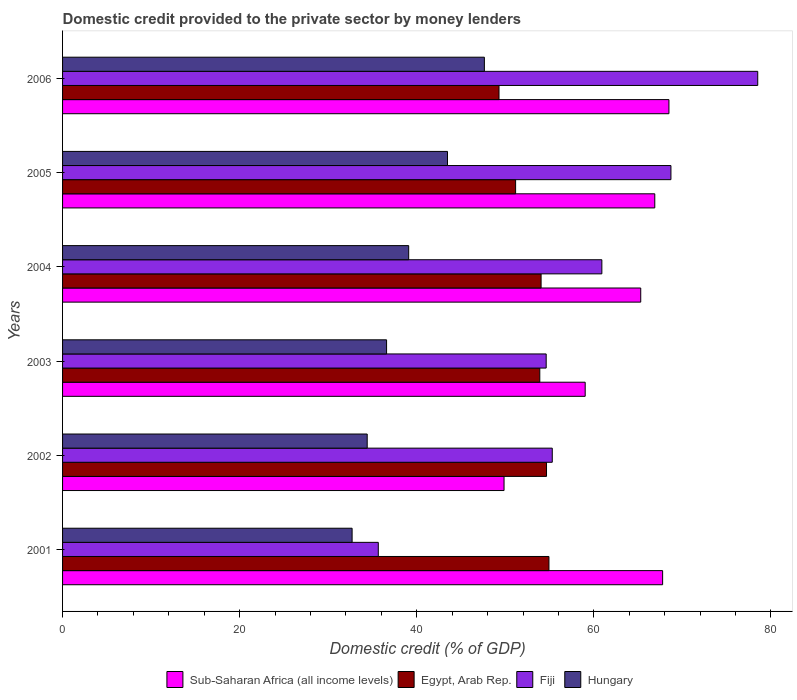How many different coloured bars are there?
Your answer should be compact. 4. How many groups of bars are there?
Make the answer very short. 6. Are the number of bars on each tick of the Y-axis equal?
Offer a very short reply. Yes. How many bars are there on the 2nd tick from the bottom?
Your answer should be very brief. 4. What is the label of the 3rd group of bars from the top?
Keep it short and to the point. 2004. What is the domestic credit provided to the private sector by money lenders in Egypt, Arab Rep. in 2003?
Keep it short and to the point. 53.9. Across all years, what is the maximum domestic credit provided to the private sector by money lenders in Egypt, Arab Rep.?
Provide a short and direct response. 54.93. Across all years, what is the minimum domestic credit provided to the private sector by money lenders in Fiji?
Your answer should be compact. 35.66. In which year was the domestic credit provided to the private sector by money lenders in Fiji maximum?
Provide a short and direct response. 2006. In which year was the domestic credit provided to the private sector by money lenders in Sub-Saharan Africa (all income levels) minimum?
Your answer should be compact. 2002. What is the total domestic credit provided to the private sector by money lenders in Sub-Saharan Africa (all income levels) in the graph?
Keep it short and to the point. 377.31. What is the difference between the domestic credit provided to the private sector by money lenders in Hungary in 2003 and that in 2004?
Provide a short and direct response. -2.5. What is the difference between the domestic credit provided to the private sector by money lenders in Fiji in 2003 and the domestic credit provided to the private sector by money lenders in Hungary in 2002?
Provide a succinct answer. 20.21. What is the average domestic credit provided to the private sector by money lenders in Fiji per year?
Your answer should be very brief. 58.95. In the year 2001, what is the difference between the domestic credit provided to the private sector by money lenders in Egypt, Arab Rep. and domestic credit provided to the private sector by money lenders in Fiji?
Your answer should be very brief. 19.27. What is the ratio of the domestic credit provided to the private sector by money lenders in Fiji in 2002 to that in 2005?
Your answer should be very brief. 0.8. What is the difference between the highest and the second highest domestic credit provided to the private sector by money lenders in Sub-Saharan Africa (all income levels)?
Provide a succinct answer. 0.71. What is the difference between the highest and the lowest domestic credit provided to the private sector by money lenders in Sub-Saharan Africa (all income levels)?
Your answer should be compact. 18.62. In how many years, is the domestic credit provided to the private sector by money lenders in Egypt, Arab Rep. greater than the average domestic credit provided to the private sector by money lenders in Egypt, Arab Rep. taken over all years?
Offer a very short reply. 4. What does the 2nd bar from the top in 2002 represents?
Your answer should be very brief. Fiji. What does the 2nd bar from the bottom in 2005 represents?
Keep it short and to the point. Egypt, Arab Rep. Is it the case that in every year, the sum of the domestic credit provided to the private sector by money lenders in Fiji and domestic credit provided to the private sector by money lenders in Sub-Saharan Africa (all income levels) is greater than the domestic credit provided to the private sector by money lenders in Egypt, Arab Rep.?
Provide a succinct answer. Yes. How many bars are there?
Give a very brief answer. 24. Are all the bars in the graph horizontal?
Your answer should be compact. Yes. Does the graph contain any zero values?
Your answer should be very brief. No. Does the graph contain grids?
Your answer should be very brief. No. Where does the legend appear in the graph?
Keep it short and to the point. Bottom center. How many legend labels are there?
Offer a terse response. 4. How are the legend labels stacked?
Make the answer very short. Horizontal. What is the title of the graph?
Provide a short and direct response. Domestic credit provided to the private sector by money lenders. Does "Faeroe Islands" appear as one of the legend labels in the graph?
Offer a terse response. No. What is the label or title of the X-axis?
Your answer should be compact. Domestic credit (% of GDP). What is the Domestic credit (% of GDP) of Sub-Saharan Africa (all income levels) in 2001?
Your answer should be very brief. 67.77. What is the Domestic credit (% of GDP) in Egypt, Arab Rep. in 2001?
Your answer should be very brief. 54.93. What is the Domestic credit (% of GDP) of Fiji in 2001?
Provide a short and direct response. 35.66. What is the Domestic credit (% of GDP) of Hungary in 2001?
Provide a short and direct response. 32.7. What is the Domestic credit (% of GDP) in Sub-Saharan Africa (all income levels) in 2002?
Your answer should be very brief. 49.86. What is the Domestic credit (% of GDP) of Egypt, Arab Rep. in 2002?
Ensure brevity in your answer.  54.66. What is the Domestic credit (% of GDP) in Fiji in 2002?
Your response must be concise. 55.31. What is the Domestic credit (% of GDP) of Hungary in 2002?
Keep it short and to the point. 34.41. What is the Domestic credit (% of GDP) of Sub-Saharan Africa (all income levels) in 2003?
Provide a short and direct response. 59.02. What is the Domestic credit (% of GDP) in Egypt, Arab Rep. in 2003?
Your response must be concise. 53.9. What is the Domestic credit (% of GDP) of Fiji in 2003?
Your answer should be very brief. 54.62. What is the Domestic credit (% of GDP) of Hungary in 2003?
Provide a succinct answer. 36.59. What is the Domestic credit (% of GDP) in Sub-Saharan Africa (all income levels) in 2004?
Offer a very short reply. 65.3. What is the Domestic credit (% of GDP) of Egypt, Arab Rep. in 2004?
Your response must be concise. 54.04. What is the Domestic credit (% of GDP) in Fiji in 2004?
Provide a short and direct response. 60.91. What is the Domestic credit (% of GDP) of Hungary in 2004?
Your answer should be compact. 39.09. What is the Domestic credit (% of GDP) of Sub-Saharan Africa (all income levels) in 2005?
Your response must be concise. 66.88. What is the Domestic credit (% of GDP) of Egypt, Arab Rep. in 2005?
Your answer should be compact. 51.17. What is the Domestic credit (% of GDP) of Fiji in 2005?
Provide a short and direct response. 68.71. What is the Domestic credit (% of GDP) of Hungary in 2005?
Your response must be concise. 43.47. What is the Domestic credit (% of GDP) in Sub-Saharan Africa (all income levels) in 2006?
Provide a succinct answer. 68.48. What is the Domestic credit (% of GDP) in Egypt, Arab Rep. in 2006?
Offer a terse response. 49.29. What is the Domestic credit (% of GDP) in Fiji in 2006?
Your answer should be very brief. 78.51. What is the Domestic credit (% of GDP) in Hungary in 2006?
Keep it short and to the point. 47.64. Across all years, what is the maximum Domestic credit (% of GDP) in Sub-Saharan Africa (all income levels)?
Keep it short and to the point. 68.48. Across all years, what is the maximum Domestic credit (% of GDP) in Egypt, Arab Rep.?
Ensure brevity in your answer.  54.93. Across all years, what is the maximum Domestic credit (% of GDP) of Fiji?
Provide a succinct answer. 78.51. Across all years, what is the maximum Domestic credit (% of GDP) in Hungary?
Give a very brief answer. 47.64. Across all years, what is the minimum Domestic credit (% of GDP) in Sub-Saharan Africa (all income levels)?
Offer a very short reply. 49.86. Across all years, what is the minimum Domestic credit (% of GDP) in Egypt, Arab Rep.?
Provide a succinct answer. 49.29. Across all years, what is the minimum Domestic credit (% of GDP) in Fiji?
Ensure brevity in your answer.  35.66. Across all years, what is the minimum Domestic credit (% of GDP) of Hungary?
Offer a very short reply. 32.7. What is the total Domestic credit (% of GDP) of Sub-Saharan Africa (all income levels) in the graph?
Make the answer very short. 377.31. What is the total Domestic credit (% of GDP) of Egypt, Arab Rep. in the graph?
Keep it short and to the point. 317.98. What is the total Domestic credit (% of GDP) in Fiji in the graph?
Your response must be concise. 353.7. What is the total Domestic credit (% of GDP) in Hungary in the graph?
Ensure brevity in your answer.  233.9. What is the difference between the Domestic credit (% of GDP) in Sub-Saharan Africa (all income levels) in 2001 and that in 2002?
Offer a terse response. 17.91. What is the difference between the Domestic credit (% of GDP) in Egypt, Arab Rep. in 2001 and that in 2002?
Your answer should be very brief. 0.28. What is the difference between the Domestic credit (% of GDP) of Fiji in 2001 and that in 2002?
Your answer should be compact. -19.65. What is the difference between the Domestic credit (% of GDP) in Hungary in 2001 and that in 2002?
Your response must be concise. -1.71. What is the difference between the Domestic credit (% of GDP) of Sub-Saharan Africa (all income levels) in 2001 and that in 2003?
Offer a terse response. 8.75. What is the difference between the Domestic credit (% of GDP) in Egypt, Arab Rep. in 2001 and that in 2003?
Your response must be concise. 1.03. What is the difference between the Domestic credit (% of GDP) of Fiji in 2001 and that in 2003?
Give a very brief answer. -18.96. What is the difference between the Domestic credit (% of GDP) in Hungary in 2001 and that in 2003?
Provide a succinct answer. -3.89. What is the difference between the Domestic credit (% of GDP) in Sub-Saharan Africa (all income levels) in 2001 and that in 2004?
Provide a succinct answer. 2.47. What is the difference between the Domestic credit (% of GDP) in Egypt, Arab Rep. in 2001 and that in 2004?
Keep it short and to the point. 0.89. What is the difference between the Domestic credit (% of GDP) of Fiji in 2001 and that in 2004?
Your answer should be very brief. -25.25. What is the difference between the Domestic credit (% of GDP) of Hungary in 2001 and that in 2004?
Your response must be concise. -6.39. What is the difference between the Domestic credit (% of GDP) in Sub-Saharan Africa (all income levels) in 2001 and that in 2005?
Ensure brevity in your answer.  0.89. What is the difference between the Domestic credit (% of GDP) of Egypt, Arab Rep. in 2001 and that in 2005?
Your answer should be very brief. 3.77. What is the difference between the Domestic credit (% of GDP) of Fiji in 2001 and that in 2005?
Provide a short and direct response. -33.05. What is the difference between the Domestic credit (% of GDP) of Hungary in 2001 and that in 2005?
Offer a terse response. -10.77. What is the difference between the Domestic credit (% of GDP) in Sub-Saharan Africa (all income levels) in 2001 and that in 2006?
Your response must be concise. -0.71. What is the difference between the Domestic credit (% of GDP) of Egypt, Arab Rep. in 2001 and that in 2006?
Offer a terse response. 5.64. What is the difference between the Domestic credit (% of GDP) of Fiji in 2001 and that in 2006?
Your answer should be compact. -42.85. What is the difference between the Domestic credit (% of GDP) in Hungary in 2001 and that in 2006?
Make the answer very short. -14.94. What is the difference between the Domestic credit (% of GDP) in Sub-Saharan Africa (all income levels) in 2002 and that in 2003?
Your response must be concise. -9.16. What is the difference between the Domestic credit (% of GDP) in Egypt, Arab Rep. in 2002 and that in 2003?
Offer a terse response. 0.76. What is the difference between the Domestic credit (% of GDP) in Fiji in 2002 and that in 2003?
Provide a succinct answer. 0.69. What is the difference between the Domestic credit (% of GDP) of Hungary in 2002 and that in 2003?
Give a very brief answer. -2.19. What is the difference between the Domestic credit (% of GDP) of Sub-Saharan Africa (all income levels) in 2002 and that in 2004?
Offer a terse response. -15.44. What is the difference between the Domestic credit (% of GDP) in Egypt, Arab Rep. in 2002 and that in 2004?
Offer a terse response. 0.61. What is the difference between the Domestic credit (% of GDP) of Fiji in 2002 and that in 2004?
Provide a short and direct response. -5.6. What is the difference between the Domestic credit (% of GDP) of Hungary in 2002 and that in 2004?
Keep it short and to the point. -4.68. What is the difference between the Domestic credit (% of GDP) in Sub-Saharan Africa (all income levels) in 2002 and that in 2005?
Your answer should be compact. -17.02. What is the difference between the Domestic credit (% of GDP) of Egypt, Arab Rep. in 2002 and that in 2005?
Offer a very short reply. 3.49. What is the difference between the Domestic credit (% of GDP) of Fiji in 2002 and that in 2005?
Make the answer very short. -13.4. What is the difference between the Domestic credit (% of GDP) of Hungary in 2002 and that in 2005?
Give a very brief answer. -9.07. What is the difference between the Domestic credit (% of GDP) of Sub-Saharan Africa (all income levels) in 2002 and that in 2006?
Your answer should be compact. -18.62. What is the difference between the Domestic credit (% of GDP) in Egypt, Arab Rep. in 2002 and that in 2006?
Make the answer very short. 5.36. What is the difference between the Domestic credit (% of GDP) in Fiji in 2002 and that in 2006?
Give a very brief answer. -23.2. What is the difference between the Domestic credit (% of GDP) in Hungary in 2002 and that in 2006?
Provide a short and direct response. -13.23. What is the difference between the Domestic credit (% of GDP) in Sub-Saharan Africa (all income levels) in 2003 and that in 2004?
Offer a very short reply. -6.27. What is the difference between the Domestic credit (% of GDP) of Egypt, Arab Rep. in 2003 and that in 2004?
Make the answer very short. -0.15. What is the difference between the Domestic credit (% of GDP) in Fiji in 2003 and that in 2004?
Keep it short and to the point. -6.29. What is the difference between the Domestic credit (% of GDP) of Hungary in 2003 and that in 2004?
Give a very brief answer. -2.5. What is the difference between the Domestic credit (% of GDP) in Sub-Saharan Africa (all income levels) in 2003 and that in 2005?
Your response must be concise. -7.86. What is the difference between the Domestic credit (% of GDP) of Egypt, Arab Rep. in 2003 and that in 2005?
Make the answer very short. 2.73. What is the difference between the Domestic credit (% of GDP) of Fiji in 2003 and that in 2005?
Offer a very short reply. -14.09. What is the difference between the Domestic credit (% of GDP) in Hungary in 2003 and that in 2005?
Your answer should be very brief. -6.88. What is the difference between the Domestic credit (% of GDP) in Sub-Saharan Africa (all income levels) in 2003 and that in 2006?
Keep it short and to the point. -9.46. What is the difference between the Domestic credit (% of GDP) in Egypt, Arab Rep. in 2003 and that in 2006?
Make the answer very short. 4.61. What is the difference between the Domestic credit (% of GDP) of Fiji in 2003 and that in 2006?
Provide a succinct answer. -23.89. What is the difference between the Domestic credit (% of GDP) in Hungary in 2003 and that in 2006?
Your answer should be compact. -11.05. What is the difference between the Domestic credit (% of GDP) of Sub-Saharan Africa (all income levels) in 2004 and that in 2005?
Your answer should be very brief. -1.59. What is the difference between the Domestic credit (% of GDP) of Egypt, Arab Rep. in 2004 and that in 2005?
Give a very brief answer. 2.88. What is the difference between the Domestic credit (% of GDP) in Fiji in 2004 and that in 2005?
Keep it short and to the point. -7.8. What is the difference between the Domestic credit (% of GDP) of Hungary in 2004 and that in 2005?
Ensure brevity in your answer.  -4.38. What is the difference between the Domestic credit (% of GDP) in Sub-Saharan Africa (all income levels) in 2004 and that in 2006?
Your answer should be very brief. -3.19. What is the difference between the Domestic credit (% of GDP) of Egypt, Arab Rep. in 2004 and that in 2006?
Provide a succinct answer. 4.75. What is the difference between the Domestic credit (% of GDP) in Fiji in 2004 and that in 2006?
Provide a succinct answer. -17.6. What is the difference between the Domestic credit (% of GDP) in Hungary in 2004 and that in 2006?
Offer a terse response. -8.55. What is the difference between the Domestic credit (% of GDP) in Sub-Saharan Africa (all income levels) in 2005 and that in 2006?
Make the answer very short. -1.6. What is the difference between the Domestic credit (% of GDP) in Egypt, Arab Rep. in 2005 and that in 2006?
Ensure brevity in your answer.  1.87. What is the difference between the Domestic credit (% of GDP) of Fiji in 2005 and that in 2006?
Your answer should be compact. -9.8. What is the difference between the Domestic credit (% of GDP) of Hungary in 2005 and that in 2006?
Make the answer very short. -4.17. What is the difference between the Domestic credit (% of GDP) in Sub-Saharan Africa (all income levels) in 2001 and the Domestic credit (% of GDP) in Egypt, Arab Rep. in 2002?
Your response must be concise. 13.11. What is the difference between the Domestic credit (% of GDP) of Sub-Saharan Africa (all income levels) in 2001 and the Domestic credit (% of GDP) of Fiji in 2002?
Your answer should be compact. 12.46. What is the difference between the Domestic credit (% of GDP) of Sub-Saharan Africa (all income levels) in 2001 and the Domestic credit (% of GDP) of Hungary in 2002?
Provide a succinct answer. 33.36. What is the difference between the Domestic credit (% of GDP) of Egypt, Arab Rep. in 2001 and the Domestic credit (% of GDP) of Fiji in 2002?
Your answer should be compact. -0.37. What is the difference between the Domestic credit (% of GDP) in Egypt, Arab Rep. in 2001 and the Domestic credit (% of GDP) in Hungary in 2002?
Your response must be concise. 20.53. What is the difference between the Domestic credit (% of GDP) of Fiji in 2001 and the Domestic credit (% of GDP) of Hungary in 2002?
Offer a terse response. 1.25. What is the difference between the Domestic credit (% of GDP) in Sub-Saharan Africa (all income levels) in 2001 and the Domestic credit (% of GDP) in Egypt, Arab Rep. in 2003?
Make the answer very short. 13.87. What is the difference between the Domestic credit (% of GDP) of Sub-Saharan Africa (all income levels) in 2001 and the Domestic credit (% of GDP) of Fiji in 2003?
Provide a short and direct response. 13.15. What is the difference between the Domestic credit (% of GDP) in Sub-Saharan Africa (all income levels) in 2001 and the Domestic credit (% of GDP) in Hungary in 2003?
Give a very brief answer. 31.18. What is the difference between the Domestic credit (% of GDP) of Egypt, Arab Rep. in 2001 and the Domestic credit (% of GDP) of Fiji in 2003?
Give a very brief answer. 0.31. What is the difference between the Domestic credit (% of GDP) in Egypt, Arab Rep. in 2001 and the Domestic credit (% of GDP) in Hungary in 2003?
Make the answer very short. 18.34. What is the difference between the Domestic credit (% of GDP) of Fiji in 2001 and the Domestic credit (% of GDP) of Hungary in 2003?
Your response must be concise. -0.94. What is the difference between the Domestic credit (% of GDP) in Sub-Saharan Africa (all income levels) in 2001 and the Domestic credit (% of GDP) in Egypt, Arab Rep. in 2004?
Your response must be concise. 13.72. What is the difference between the Domestic credit (% of GDP) of Sub-Saharan Africa (all income levels) in 2001 and the Domestic credit (% of GDP) of Fiji in 2004?
Keep it short and to the point. 6.86. What is the difference between the Domestic credit (% of GDP) in Sub-Saharan Africa (all income levels) in 2001 and the Domestic credit (% of GDP) in Hungary in 2004?
Give a very brief answer. 28.68. What is the difference between the Domestic credit (% of GDP) of Egypt, Arab Rep. in 2001 and the Domestic credit (% of GDP) of Fiji in 2004?
Make the answer very short. -5.97. What is the difference between the Domestic credit (% of GDP) in Egypt, Arab Rep. in 2001 and the Domestic credit (% of GDP) in Hungary in 2004?
Your response must be concise. 15.84. What is the difference between the Domestic credit (% of GDP) in Fiji in 2001 and the Domestic credit (% of GDP) in Hungary in 2004?
Your answer should be compact. -3.43. What is the difference between the Domestic credit (% of GDP) in Sub-Saharan Africa (all income levels) in 2001 and the Domestic credit (% of GDP) in Egypt, Arab Rep. in 2005?
Provide a short and direct response. 16.6. What is the difference between the Domestic credit (% of GDP) in Sub-Saharan Africa (all income levels) in 2001 and the Domestic credit (% of GDP) in Fiji in 2005?
Give a very brief answer. -0.94. What is the difference between the Domestic credit (% of GDP) of Sub-Saharan Africa (all income levels) in 2001 and the Domestic credit (% of GDP) of Hungary in 2005?
Provide a succinct answer. 24.3. What is the difference between the Domestic credit (% of GDP) in Egypt, Arab Rep. in 2001 and the Domestic credit (% of GDP) in Fiji in 2005?
Keep it short and to the point. -13.78. What is the difference between the Domestic credit (% of GDP) in Egypt, Arab Rep. in 2001 and the Domestic credit (% of GDP) in Hungary in 2005?
Provide a succinct answer. 11.46. What is the difference between the Domestic credit (% of GDP) of Fiji in 2001 and the Domestic credit (% of GDP) of Hungary in 2005?
Provide a succinct answer. -7.82. What is the difference between the Domestic credit (% of GDP) in Sub-Saharan Africa (all income levels) in 2001 and the Domestic credit (% of GDP) in Egypt, Arab Rep. in 2006?
Your response must be concise. 18.48. What is the difference between the Domestic credit (% of GDP) in Sub-Saharan Africa (all income levels) in 2001 and the Domestic credit (% of GDP) in Fiji in 2006?
Give a very brief answer. -10.74. What is the difference between the Domestic credit (% of GDP) in Sub-Saharan Africa (all income levels) in 2001 and the Domestic credit (% of GDP) in Hungary in 2006?
Offer a terse response. 20.13. What is the difference between the Domestic credit (% of GDP) in Egypt, Arab Rep. in 2001 and the Domestic credit (% of GDP) in Fiji in 2006?
Your answer should be compact. -23.58. What is the difference between the Domestic credit (% of GDP) of Egypt, Arab Rep. in 2001 and the Domestic credit (% of GDP) of Hungary in 2006?
Provide a short and direct response. 7.29. What is the difference between the Domestic credit (% of GDP) of Fiji in 2001 and the Domestic credit (% of GDP) of Hungary in 2006?
Keep it short and to the point. -11.98. What is the difference between the Domestic credit (% of GDP) of Sub-Saharan Africa (all income levels) in 2002 and the Domestic credit (% of GDP) of Egypt, Arab Rep. in 2003?
Provide a succinct answer. -4.04. What is the difference between the Domestic credit (% of GDP) in Sub-Saharan Africa (all income levels) in 2002 and the Domestic credit (% of GDP) in Fiji in 2003?
Your answer should be very brief. -4.76. What is the difference between the Domestic credit (% of GDP) in Sub-Saharan Africa (all income levels) in 2002 and the Domestic credit (% of GDP) in Hungary in 2003?
Ensure brevity in your answer.  13.27. What is the difference between the Domestic credit (% of GDP) in Egypt, Arab Rep. in 2002 and the Domestic credit (% of GDP) in Fiji in 2003?
Provide a short and direct response. 0.04. What is the difference between the Domestic credit (% of GDP) in Egypt, Arab Rep. in 2002 and the Domestic credit (% of GDP) in Hungary in 2003?
Give a very brief answer. 18.06. What is the difference between the Domestic credit (% of GDP) of Fiji in 2002 and the Domestic credit (% of GDP) of Hungary in 2003?
Your answer should be very brief. 18.71. What is the difference between the Domestic credit (% of GDP) of Sub-Saharan Africa (all income levels) in 2002 and the Domestic credit (% of GDP) of Egypt, Arab Rep. in 2004?
Keep it short and to the point. -4.18. What is the difference between the Domestic credit (% of GDP) in Sub-Saharan Africa (all income levels) in 2002 and the Domestic credit (% of GDP) in Fiji in 2004?
Ensure brevity in your answer.  -11.05. What is the difference between the Domestic credit (% of GDP) of Sub-Saharan Africa (all income levels) in 2002 and the Domestic credit (% of GDP) of Hungary in 2004?
Your answer should be very brief. 10.77. What is the difference between the Domestic credit (% of GDP) of Egypt, Arab Rep. in 2002 and the Domestic credit (% of GDP) of Fiji in 2004?
Keep it short and to the point. -6.25. What is the difference between the Domestic credit (% of GDP) of Egypt, Arab Rep. in 2002 and the Domestic credit (% of GDP) of Hungary in 2004?
Keep it short and to the point. 15.57. What is the difference between the Domestic credit (% of GDP) of Fiji in 2002 and the Domestic credit (% of GDP) of Hungary in 2004?
Your answer should be very brief. 16.22. What is the difference between the Domestic credit (% of GDP) of Sub-Saharan Africa (all income levels) in 2002 and the Domestic credit (% of GDP) of Egypt, Arab Rep. in 2005?
Your response must be concise. -1.31. What is the difference between the Domestic credit (% of GDP) of Sub-Saharan Africa (all income levels) in 2002 and the Domestic credit (% of GDP) of Fiji in 2005?
Offer a terse response. -18.85. What is the difference between the Domestic credit (% of GDP) of Sub-Saharan Africa (all income levels) in 2002 and the Domestic credit (% of GDP) of Hungary in 2005?
Your answer should be compact. 6.39. What is the difference between the Domestic credit (% of GDP) of Egypt, Arab Rep. in 2002 and the Domestic credit (% of GDP) of Fiji in 2005?
Ensure brevity in your answer.  -14.05. What is the difference between the Domestic credit (% of GDP) in Egypt, Arab Rep. in 2002 and the Domestic credit (% of GDP) in Hungary in 2005?
Make the answer very short. 11.18. What is the difference between the Domestic credit (% of GDP) of Fiji in 2002 and the Domestic credit (% of GDP) of Hungary in 2005?
Your answer should be very brief. 11.83. What is the difference between the Domestic credit (% of GDP) of Sub-Saharan Africa (all income levels) in 2002 and the Domestic credit (% of GDP) of Egypt, Arab Rep. in 2006?
Offer a terse response. 0.57. What is the difference between the Domestic credit (% of GDP) in Sub-Saharan Africa (all income levels) in 2002 and the Domestic credit (% of GDP) in Fiji in 2006?
Ensure brevity in your answer.  -28.65. What is the difference between the Domestic credit (% of GDP) in Sub-Saharan Africa (all income levels) in 2002 and the Domestic credit (% of GDP) in Hungary in 2006?
Keep it short and to the point. 2.22. What is the difference between the Domestic credit (% of GDP) in Egypt, Arab Rep. in 2002 and the Domestic credit (% of GDP) in Fiji in 2006?
Ensure brevity in your answer.  -23.85. What is the difference between the Domestic credit (% of GDP) in Egypt, Arab Rep. in 2002 and the Domestic credit (% of GDP) in Hungary in 2006?
Make the answer very short. 7.02. What is the difference between the Domestic credit (% of GDP) of Fiji in 2002 and the Domestic credit (% of GDP) of Hungary in 2006?
Provide a succinct answer. 7.67. What is the difference between the Domestic credit (% of GDP) in Sub-Saharan Africa (all income levels) in 2003 and the Domestic credit (% of GDP) in Egypt, Arab Rep. in 2004?
Provide a succinct answer. 4.98. What is the difference between the Domestic credit (% of GDP) in Sub-Saharan Africa (all income levels) in 2003 and the Domestic credit (% of GDP) in Fiji in 2004?
Provide a short and direct response. -1.88. What is the difference between the Domestic credit (% of GDP) of Sub-Saharan Africa (all income levels) in 2003 and the Domestic credit (% of GDP) of Hungary in 2004?
Provide a succinct answer. 19.93. What is the difference between the Domestic credit (% of GDP) in Egypt, Arab Rep. in 2003 and the Domestic credit (% of GDP) in Fiji in 2004?
Your answer should be very brief. -7.01. What is the difference between the Domestic credit (% of GDP) in Egypt, Arab Rep. in 2003 and the Domestic credit (% of GDP) in Hungary in 2004?
Offer a terse response. 14.81. What is the difference between the Domestic credit (% of GDP) in Fiji in 2003 and the Domestic credit (% of GDP) in Hungary in 2004?
Give a very brief answer. 15.53. What is the difference between the Domestic credit (% of GDP) in Sub-Saharan Africa (all income levels) in 2003 and the Domestic credit (% of GDP) in Egypt, Arab Rep. in 2005?
Offer a very short reply. 7.86. What is the difference between the Domestic credit (% of GDP) of Sub-Saharan Africa (all income levels) in 2003 and the Domestic credit (% of GDP) of Fiji in 2005?
Provide a short and direct response. -9.68. What is the difference between the Domestic credit (% of GDP) of Sub-Saharan Africa (all income levels) in 2003 and the Domestic credit (% of GDP) of Hungary in 2005?
Your answer should be compact. 15.55. What is the difference between the Domestic credit (% of GDP) in Egypt, Arab Rep. in 2003 and the Domestic credit (% of GDP) in Fiji in 2005?
Make the answer very short. -14.81. What is the difference between the Domestic credit (% of GDP) of Egypt, Arab Rep. in 2003 and the Domestic credit (% of GDP) of Hungary in 2005?
Ensure brevity in your answer.  10.43. What is the difference between the Domestic credit (% of GDP) of Fiji in 2003 and the Domestic credit (% of GDP) of Hungary in 2005?
Give a very brief answer. 11.15. What is the difference between the Domestic credit (% of GDP) of Sub-Saharan Africa (all income levels) in 2003 and the Domestic credit (% of GDP) of Egypt, Arab Rep. in 2006?
Your answer should be compact. 9.73. What is the difference between the Domestic credit (% of GDP) of Sub-Saharan Africa (all income levels) in 2003 and the Domestic credit (% of GDP) of Fiji in 2006?
Your answer should be very brief. -19.49. What is the difference between the Domestic credit (% of GDP) in Sub-Saharan Africa (all income levels) in 2003 and the Domestic credit (% of GDP) in Hungary in 2006?
Your answer should be very brief. 11.38. What is the difference between the Domestic credit (% of GDP) in Egypt, Arab Rep. in 2003 and the Domestic credit (% of GDP) in Fiji in 2006?
Give a very brief answer. -24.61. What is the difference between the Domestic credit (% of GDP) of Egypt, Arab Rep. in 2003 and the Domestic credit (% of GDP) of Hungary in 2006?
Offer a very short reply. 6.26. What is the difference between the Domestic credit (% of GDP) in Fiji in 2003 and the Domestic credit (% of GDP) in Hungary in 2006?
Make the answer very short. 6.98. What is the difference between the Domestic credit (% of GDP) of Sub-Saharan Africa (all income levels) in 2004 and the Domestic credit (% of GDP) of Egypt, Arab Rep. in 2005?
Offer a terse response. 14.13. What is the difference between the Domestic credit (% of GDP) in Sub-Saharan Africa (all income levels) in 2004 and the Domestic credit (% of GDP) in Fiji in 2005?
Offer a very short reply. -3.41. What is the difference between the Domestic credit (% of GDP) of Sub-Saharan Africa (all income levels) in 2004 and the Domestic credit (% of GDP) of Hungary in 2005?
Provide a succinct answer. 21.82. What is the difference between the Domestic credit (% of GDP) in Egypt, Arab Rep. in 2004 and the Domestic credit (% of GDP) in Fiji in 2005?
Make the answer very short. -14.66. What is the difference between the Domestic credit (% of GDP) in Egypt, Arab Rep. in 2004 and the Domestic credit (% of GDP) in Hungary in 2005?
Your answer should be very brief. 10.57. What is the difference between the Domestic credit (% of GDP) of Fiji in 2004 and the Domestic credit (% of GDP) of Hungary in 2005?
Give a very brief answer. 17.43. What is the difference between the Domestic credit (% of GDP) in Sub-Saharan Africa (all income levels) in 2004 and the Domestic credit (% of GDP) in Egypt, Arab Rep. in 2006?
Ensure brevity in your answer.  16. What is the difference between the Domestic credit (% of GDP) of Sub-Saharan Africa (all income levels) in 2004 and the Domestic credit (% of GDP) of Fiji in 2006?
Your answer should be very brief. -13.21. What is the difference between the Domestic credit (% of GDP) of Sub-Saharan Africa (all income levels) in 2004 and the Domestic credit (% of GDP) of Hungary in 2006?
Ensure brevity in your answer.  17.66. What is the difference between the Domestic credit (% of GDP) of Egypt, Arab Rep. in 2004 and the Domestic credit (% of GDP) of Fiji in 2006?
Your answer should be compact. -24.47. What is the difference between the Domestic credit (% of GDP) in Egypt, Arab Rep. in 2004 and the Domestic credit (% of GDP) in Hungary in 2006?
Give a very brief answer. 6.41. What is the difference between the Domestic credit (% of GDP) in Fiji in 2004 and the Domestic credit (% of GDP) in Hungary in 2006?
Offer a terse response. 13.27. What is the difference between the Domestic credit (% of GDP) in Sub-Saharan Africa (all income levels) in 2005 and the Domestic credit (% of GDP) in Egypt, Arab Rep. in 2006?
Your answer should be compact. 17.59. What is the difference between the Domestic credit (% of GDP) of Sub-Saharan Africa (all income levels) in 2005 and the Domestic credit (% of GDP) of Fiji in 2006?
Make the answer very short. -11.63. What is the difference between the Domestic credit (% of GDP) in Sub-Saharan Africa (all income levels) in 2005 and the Domestic credit (% of GDP) in Hungary in 2006?
Keep it short and to the point. 19.24. What is the difference between the Domestic credit (% of GDP) in Egypt, Arab Rep. in 2005 and the Domestic credit (% of GDP) in Fiji in 2006?
Give a very brief answer. -27.34. What is the difference between the Domestic credit (% of GDP) of Egypt, Arab Rep. in 2005 and the Domestic credit (% of GDP) of Hungary in 2006?
Offer a terse response. 3.53. What is the difference between the Domestic credit (% of GDP) of Fiji in 2005 and the Domestic credit (% of GDP) of Hungary in 2006?
Give a very brief answer. 21.07. What is the average Domestic credit (% of GDP) of Sub-Saharan Africa (all income levels) per year?
Your answer should be very brief. 62.88. What is the average Domestic credit (% of GDP) of Egypt, Arab Rep. per year?
Your response must be concise. 53. What is the average Domestic credit (% of GDP) of Fiji per year?
Your answer should be very brief. 58.95. What is the average Domestic credit (% of GDP) of Hungary per year?
Offer a terse response. 38.98. In the year 2001, what is the difference between the Domestic credit (% of GDP) of Sub-Saharan Africa (all income levels) and Domestic credit (% of GDP) of Egypt, Arab Rep.?
Offer a terse response. 12.84. In the year 2001, what is the difference between the Domestic credit (% of GDP) of Sub-Saharan Africa (all income levels) and Domestic credit (% of GDP) of Fiji?
Provide a short and direct response. 32.11. In the year 2001, what is the difference between the Domestic credit (% of GDP) in Sub-Saharan Africa (all income levels) and Domestic credit (% of GDP) in Hungary?
Give a very brief answer. 35.07. In the year 2001, what is the difference between the Domestic credit (% of GDP) of Egypt, Arab Rep. and Domestic credit (% of GDP) of Fiji?
Your answer should be very brief. 19.27. In the year 2001, what is the difference between the Domestic credit (% of GDP) of Egypt, Arab Rep. and Domestic credit (% of GDP) of Hungary?
Offer a terse response. 22.23. In the year 2001, what is the difference between the Domestic credit (% of GDP) of Fiji and Domestic credit (% of GDP) of Hungary?
Your response must be concise. 2.96. In the year 2002, what is the difference between the Domestic credit (% of GDP) of Sub-Saharan Africa (all income levels) and Domestic credit (% of GDP) of Egypt, Arab Rep.?
Offer a very short reply. -4.8. In the year 2002, what is the difference between the Domestic credit (% of GDP) in Sub-Saharan Africa (all income levels) and Domestic credit (% of GDP) in Fiji?
Provide a succinct answer. -5.45. In the year 2002, what is the difference between the Domestic credit (% of GDP) in Sub-Saharan Africa (all income levels) and Domestic credit (% of GDP) in Hungary?
Provide a short and direct response. 15.45. In the year 2002, what is the difference between the Domestic credit (% of GDP) of Egypt, Arab Rep. and Domestic credit (% of GDP) of Fiji?
Make the answer very short. -0.65. In the year 2002, what is the difference between the Domestic credit (% of GDP) of Egypt, Arab Rep. and Domestic credit (% of GDP) of Hungary?
Your answer should be compact. 20.25. In the year 2002, what is the difference between the Domestic credit (% of GDP) of Fiji and Domestic credit (% of GDP) of Hungary?
Make the answer very short. 20.9. In the year 2003, what is the difference between the Domestic credit (% of GDP) in Sub-Saharan Africa (all income levels) and Domestic credit (% of GDP) in Egypt, Arab Rep.?
Provide a succinct answer. 5.13. In the year 2003, what is the difference between the Domestic credit (% of GDP) of Sub-Saharan Africa (all income levels) and Domestic credit (% of GDP) of Fiji?
Your answer should be very brief. 4.4. In the year 2003, what is the difference between the Domestic credit (% of GDP) in Sub-Saharan Africa (all income levels) and Domestic credit (% of GDP) in Hungary?
Make the answer very short. 22.43. In the year 2003, what is the difference between the Domestic credit (% of GDP) in Egypt, Arab Rep. and Domestic credit (% of GDP) in Fiji?
Your answer should be compact. -0.72. In the year 2003, what is the difference between the Domestic credit (% of GDP) in Egypt, Arab Rep. and Domestic credit (% of GDP) in Hungary?
Offer a terse response. 17.31. In the year 2003, what is the difference between the Domestic credit (% of GDP) of Fiji and Domestic credit (% of GDP) of Hungary?
Make the answer very short. 18.03. In the year 2004, what is the difference between the Domestic credit (% of GDP) of Sub-Saharan Africa (all income levels) and Domestic credit (% of GDP) of Egypt, Arab Rep.?
Your answer should be very brief. 11.25. In the year 2004, what is the difference between the Domestic credit (% of GDP) of Sub-Saharan Africa (all income levels) and Domestic credit (% of GDP) of Fiji?
Provide a short and direct response. 4.39. In the year 2004, what is the difference between the Domestic credit (% of GDP) of Sub-Saharan Africa (all income levels) and Domestic credit (% of GDP) of Hungary?
Provide a short and direct response. 26.21. In the year 2004, what is the difference between the Domestic credit (% of GDP) in Egypt, Arab Rep. and Domestic credit (% of GDP) in Fiji?
Ensure brevity in your answer.  -6.86. In the year 2004, what is the difference between the Domestic credit (% of GDP) in Egypt, Arab Rep. and Domestic credit (% of GDP) in Hungary?
Make the answer very short. 14.95. In the year 2004, what is the difference between the Domestic credit (% of GDP) of Fiji and Domestic credit (% of GDP) of Hungary?
Give a very brief answer. 21.82. In the year 2005, what is the difference between the Domestic credit (% of GDP) of Sub-Saharan Africa (all income levels) and Domestic credit (% of GDP) of Egypt, Arab Rep.?
Your answer should be compact. 15.72. In the year 2005, what is the difference between the Domestic credit (% of GDP) of Sub-Saharan Africa (all income levels) and Domestic credit (% of GDP) of Fiji?
Offer a very short reply. -1.82. In the year 2005, what is the difference between the Domestic credit (% of GDP) of Sub-Saharan Africa (all income levels) and Domestic credit (% of GDP) of Hungary?
Provide a succinct answer. 23.41. In the year 2005, what is the difference between the Domestic credit (% of GDP) of Egypt, Arab Rep. and Domestic credit (% of GDP) of Fiji?
Your answer should be very brief. -17.54. In the year 2005, what is the difference between the Domestic credit (% of GDP) in Egypt, Arab Rep. and Domestic credit (% of GDP) in Hungary?
Your answer should be very brief. 7.69. In the year 2005, what is the difference between the Domestic credit (% of GDP) in Fiji and Domestic credit (% of GDP) in Hungary?
Give a very brief answer. 25.23. In the year 2006, what is the difference between the Domestic credit (% of GDP) in Sub-Saharan Africa (all income levels) and Domestic credit (% of GDP) in Egypt, Arab Rep.?
Keep it short and to the point. 19.19. In the year 2006, what is the difference between the Domestic credit (% of GDP) in Sub-Saharan Africa (all income levels) and Domestic credit (% of GDP) in Fiji?
Your response must be concise. -10.03. In the year 2006, what is the difference between the Domestic credit (% of GDP) of Sub-Saharan Africa (all income levels) and Domestic credit (% of GDP) of Hungary?
Your answer should be very brief. 20.84. In the year 2006, what is the difference between the Domestic credit (% of GDP) of Egypt, Arab Rep. and Domestic credit (% of GDP) of Fiji?
Provide a short and direct response. -29.22. In the year 2006, what is the difference between the Domestic credit (% of GDP) in Egypt, Arab Rep. and Domestic credit (% of GDP) in Hungary?
Provide a succinct answer. 1.65. In the year 2006, what is the difference between the Domestic credit (% of GDP) of Fiji and Domestic credit (% of GDP) of Hungary?
Give a very brief answer. 30.87. What is the ratio of the Domestic credit (% of GDP) in Sub-Saharan Africa (all income levels) in 2001 to that in 2002?
Ensure brevity in your answer.  1.36. What is the ratio of the Domestic credit (% of GDP) in Egypt, Arab Rep. in 2001 to that in 2002?
Provide a succinct answer. 1. What is the ratio of the Domestic credit (% of GDP) in Fiji in 2001 to that in 2002?
Provide a succinct answer. 0.64. What is the ratio of the Domestic credit (% of GDP) of Hungary in 2001 to that in 2002?
Your answer should be very brief. 0.95. What is the ratio of the Domestic credit (% of GDP) of Sub-Saharan Africa (all income levels) in 2001 to that in 2003?
Your response must be concise. 1.15. What is the ratio of the Domestic credit (% of GDP) of Egypt, Arab Rep. in 2001 to that in 2003?
Give a very brief answer. 1.02. What is the ratio of the Domestic credit (% of GDP) in Fiji in 2001 to that in 2003?
Ensure brevity in your answer.  0.65. What is the ratio of the Domestic credit (% of GDP) of Hungary in 2001 to that in 2003?
Make the answer very short. 0.89. What is the ratio of the Domestic credit (% of GDP) of Sub-Saharan Africa (all income levels) in 2001 to that in 2004?
Ensure brevity in your answer.  1.04. What is the ratio of the Domestic credit (% of GDP) in Egypt, Arab Rep. in 2001 to that in 2004?
Provide a short and direct response. 1.02. What is the ratio of the Domestic credit (% of GDP) of Fiji in 2001 to that in 2004?
Your answer should be compact. 0.59. What is the ratio of the Domestic credit (% of GDP) in Hungary in 2001 to that in 2004?
Offer a terse response. 0.84. What is the ratio of the Domestic credit (% of GDP) of Sub-Saharan Africa (all income levels) in 2001 to that in 2005?
Your answer should be very brief. 1.01. What is the ratio of the Domestic credit (% of GDP) in Egypt, Arab Rep. in 2001 to that in 2005?
Provide a succinct answer. 1.07. What is the ratio of the Domestic credit (% of GDP) in Fiji in 2001 to that in 2005?
Keep it short and to the point. 0.52. What is the ratio of the Domestic credit (% of GDP) of Hungary in 2001 to that in 2005?
Your response must be concise. 0.75. What is the ratio of the Domestic credit (% of GDP) of Sub-Saharan Africa (all income levels) in 2001 to that in 2006?
Provide a succinct answer. 0.99. What is the ratio of the Domestic credit (% of GDP) in Egypt, Arab Rep. in 2001 to that in 2006?
Your answer should be compact. 1.11. What is the ratio of the Domestic credit (% of GDP) of Fiji in 2001 to that in 2006?
Ensure brevity in your answer.  0.45. What is the ratio of the Domestic credit (% of GDP) in Hungary in 2001 to that in 2006?
Your answer should be compact. 0.69. What is the ratio of the Domestic credit (% of GDP) of Sub-Saharan Africa (all income levels) in 2002 to that in 2003?
Offer a terse response. 0.84. What is the ratio of the Domestic credit (% of GDP) in Egypt, Arab Rep. in 2002 to that in 2003?
Offer a very short reply. 1.01. What is the ratio of the Domestic credit (% of GDP) of Fiji in 2002 to that in 2003?
Offer a very short reply. 1.01. What is the ratio of the Domestic credit (% of GDP) of Hungary in 2002 to that in 2003?
Your response must be concise. 0.94. What is the ratio of the Domestic credit (% of GDP) in Sub-Saharan Africa (all income levels) in 2002 to that in 2004?
Keep it short and to the point. 0.76. What is the ratio of the Domestic credit (% of GDP) of Egypt, Arab Rep. in 2002 to that in 2004?
Give a very brief answer. 1.01. What is the ratio of the Domestic credit (% of GDP) of Fiji in 2002 to that in 2004?
Make the answer very short. 0.91. What is the ratio of the Domestic credit (% of GDP) in Hungary in 2002 to that in 2004?
Ensure brevity in your answer.  0.88. What is the ratio of the Domestic credit (% of GDP) in Sub-Saharan Africa (all income levels) in 2002 to that in 2005?
Provide a succinct answer. 0.75. What is the ratio of the Domestic credit (% of GDP) in Egypt, Arab Rep. in 2002 to that in 2005?
Provide a succinct answer. 1.07. What is the ratio of the Domestic credit (% of GDP) in Fiji in 2002 to that in 2005?
Provide a succinct answer. 0.81. What is the ratio of the Domestic credit (% of GDP) of Hungary in 2002 to that in 2005?
Keep it short and to the point. 0.79. What is the ratio of the Domestic credit (% of GDP) of Sub-Saharan Africa (all income levels) in 2002 to that in 2006?
Your response must be concise. 0.73. What is the ratio of the Domestic credit (% of GDP) in Egypt, Arab Rep. in 2002 to that in 2006?
Offer a very short reply. 1.11. What is the ratio of the Domestic credit (% of GDP) in Fiji in 2002 to that in 2006?
Your answer should be compact. 0.7. What is the ratio of the Domestic credit (% of GDP) in Hungary in 2002 to that in 2006?
Make the answer very short. 0.72. What is the ratio of the Domestic credit (% of GDP) of Sub-Saharan Africa (all income levels) in 2003 to that in 2004?
Keep it short and to the point. 0.9. What is the ratio of the Domestic credit (% of GDP) in Egypt, Arab Rep. in 2003 to that in 2004?
Offer a terse response. 1. What is the ratio of the Domestic credit (% of GDP) of Fiji in 2003 to that in 2004?
Make the answer very short. 0.9. What is the ratio of the Domestic credit (% of GDP) of Hungary in 2003 to that in 2004?
Offer a terse response. 0.94. What is the ratio of the Domestic credit (% of GDP) in Sub-Saharan Africa (all income levels) in 2003 to that in 2005?
Ensure brevity in your answer.  0.88. What is the ratio of the Domestic credit (% of GDP) of Egypt, Arab Rep. in 2003 to that in 2005?
Provide a short and direct response. 1.05. What is the ratio of the Domestic credit (% of GDP) of Fiji in 2003 to that in 2005?
Give a very brief answer. 0.8. What is the ratio of the Domestic credit (% of GDP) of Hungary in 2003 to that in 2005?
Your answer should be compact. 0.84. What is the ratio of the Domestic credit (% of GDP) of Sub-Saharan Africa (all income levels) in 2003 to that in 2006?
Your response must be concise. 0.86. What is the ratio of the Domestic credit (% of GDP) in Egypt, Arab Rep. in 2003 to that in 2006?
Keep it short and to the point. 1.09. What is the ratio of the Domestic credit (% of GDP) of Fiji in 2003 to that in 2006?
Offer a very short reply. 0.7. What is the ratio of the Domestic credit (% of GDP) in Hungary in 2003 to that in 2006?
Offer a very short reply. 0.77. What is the ratio of the Domestic credit (% of GDP) in Sub-Saharan Africa (all income levels) in 2004 to that in 2005?
Offer a very short reply. 0.98. What is the ratio of the Domestic credit (% of GDP) in Egypt, Arab Rep. in 2004 to that in 2005?
Your answer should be compact. 1.06. What is the ratio of the Domestic credit (% of GDP) of Fiji in 2004 to that in 2005?
Provide a short and direct response. 0.89. What is the ratio of the Domestic credit (% of GDP) in Hungary in 2004 to that in 2005?
Provide a short and direct response. 0.9. What is the ratio of the Domestic credit (% of GDP) in Sub-Saharan Africa (all income levels) in 2004 to that in 2006?
Make the answer very short. 0.95. What is the ratio of the Domestic credit (% of GDP) in Egypt, Arab Rep. in 2004 to that in 2006?
Your response must be concise. 1.1. What is the ratio of the Domestic credit (% of GDP) in Fiji in 2004 to that in 2006?
Your response must be concise. 0.78. What is the ratio of the Domestic credit (% of GDP) of Hungary in 2004 to that in 2006?
Your response must be concise. 0.82. What is the ratio of the Domestic credit (% of GDP) of Sub-Saharan Africa (all income levels) in 2005 to that in 2006?
Make the answer very short. 0.98. What is the ratio of the Domestic credit (% of GDP) in Egypt, Arab Rep. in 2005 to that in 2006?
Your answer should be very brief. 1.04. What is the ratio of the Domestic credit (% of GDP) in Fiji in 2005 to that in 2006?
Offer a terse response. 0.88. What is the ratio of the Domestic credit (% of GDP) in Hungary in 2005 to that in 2006?
Ensure brevity in your answer.  0.91. What is the difference between the highest and the second highest Domestic credit (% of GDP) in Sub-Saharan Africa (all income levels)?
Offer a terse response. 0.71. What is the difference between the highest and the second highest Domestic credit (% of GDP) of Egypt, Arab Rep.?
Give a very brief answer. 0.28. What is the difference between the highest and the second highest Domestic credit (% of GDP) of Fiji?
Make the answer very short. 9.8. What is the difference between the highest and the second highest Domestic credit (% of GDP) of Hungary?
Provide a short and direct response. 4.17. What is the difference between the highest and the lowest Domestic credit (% of GDP) in Sub-Saharan Africa (all income levels)?
Offer a terse response. 18.62. What is the difference between the highest and the lowest Domestic credit (% of GDP) of Egypt, Arab Rep.?
Keep it short and to the point. 5.64. What is the difference between the highest and the lowest Domestic credit (% of GDP) of Fiji?
Provide a short and direct response. 42.85. What is the difference between the highest and the lowest Domestic credit (% of GDP) in Hungary?
Your answer should be compact. 14.94. 